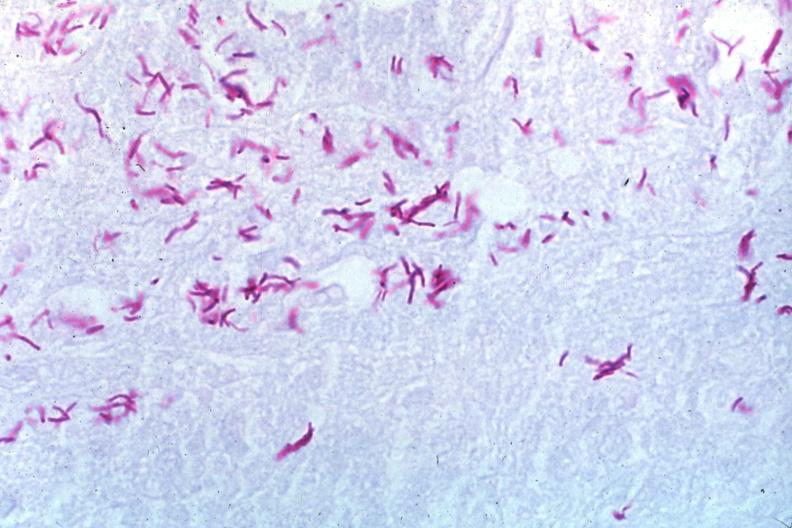s fibroma present?
Answer the question using a single word or phrase. No 